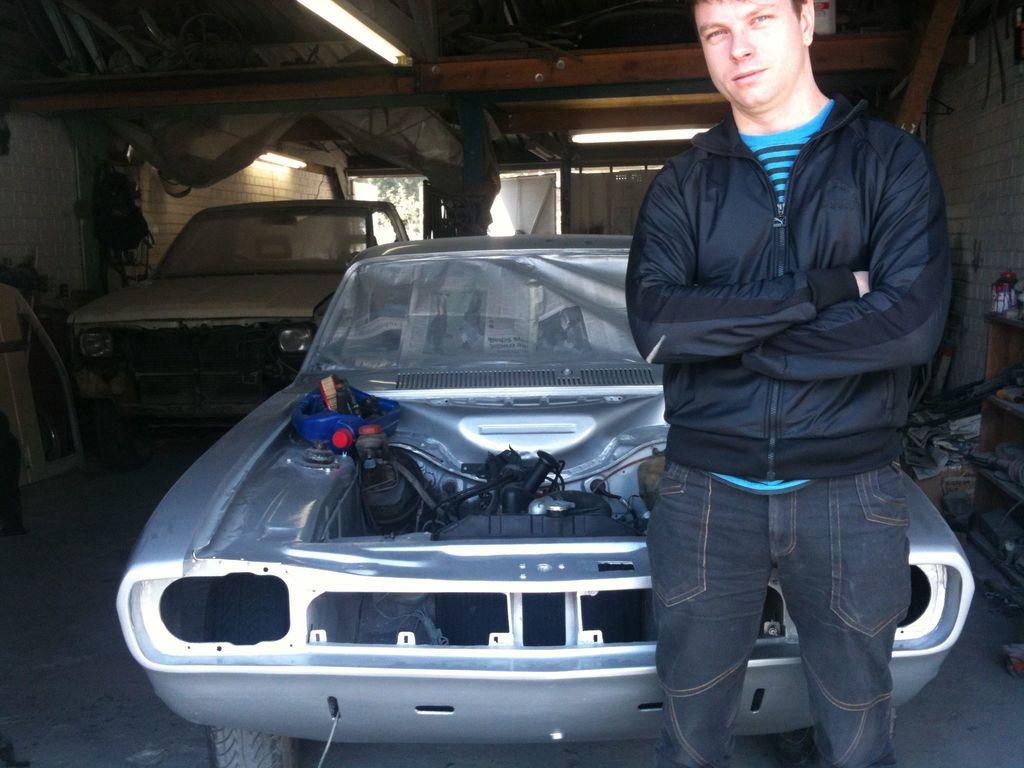Describe this image in one or two sentences. In this image we can see two cars and a person standing in front of a car, there are lights to the ceiling and there is a rack with few objects beside the person, there is a door and a tree in the background. 